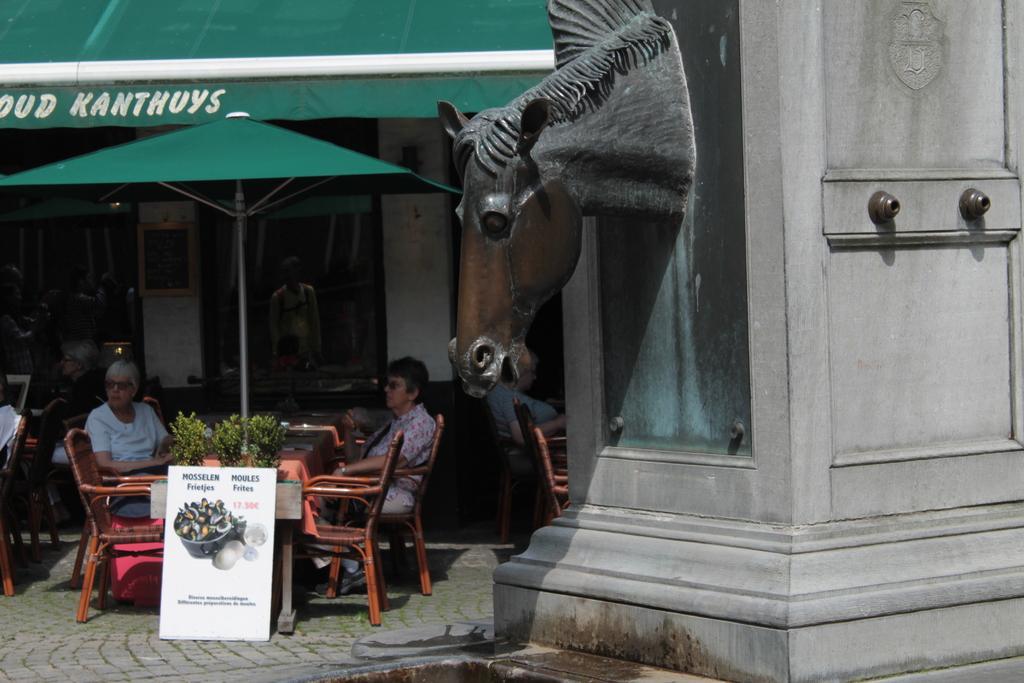Can you describe this image briefly? In this picture, we see two women sitting on either side of the table. On table, we see flower pot and beside that, we see a whiteboard with some text on it. Behind them, we see a restaurant and above that we see a green tent and a roof with green in color. On the left right corner of the picture, we see a pillar and a horse carved on it. 